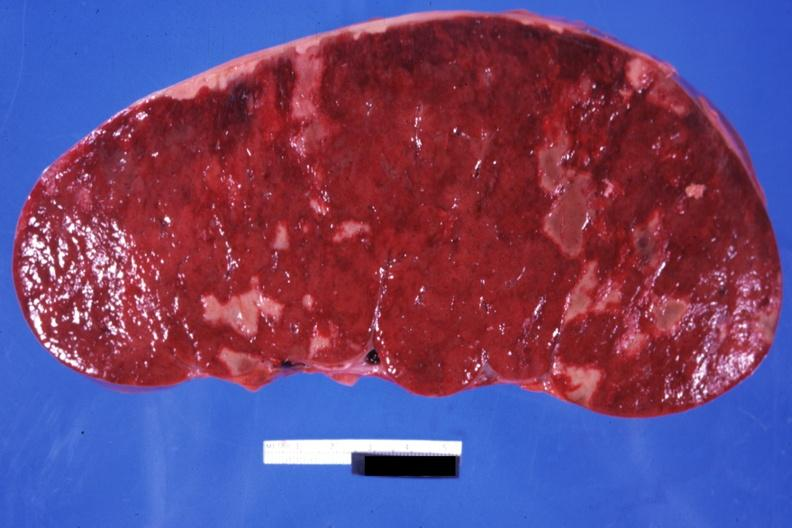what is easily seen?
Answer the question using a single word or phrase. Infiltrative process 